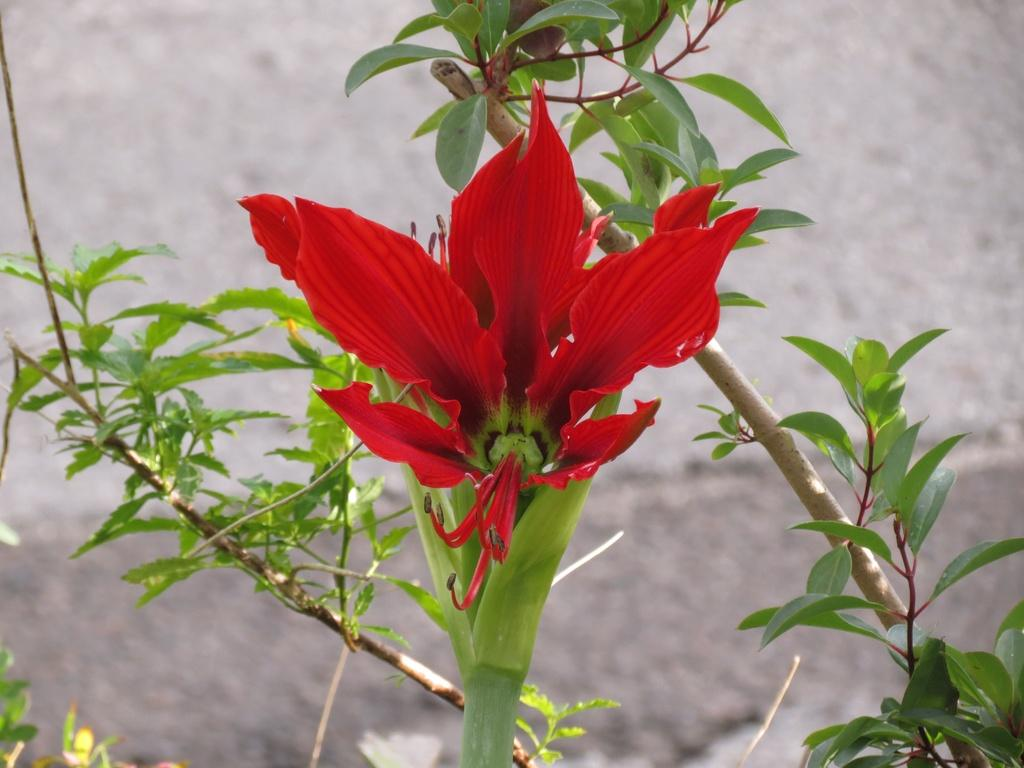What is the main subject of the image? There is a flower in the image. What is the color of the flower? The flower is red in color. What parts of the flower can be seen in the image? There is a stem and leaves associated with the flower. How would you describe the background of the image? The background of the image is blurred. How much profit does the flesh in the image generate? There is no flesh present in the image, and therefore no profit can be generated from it. 